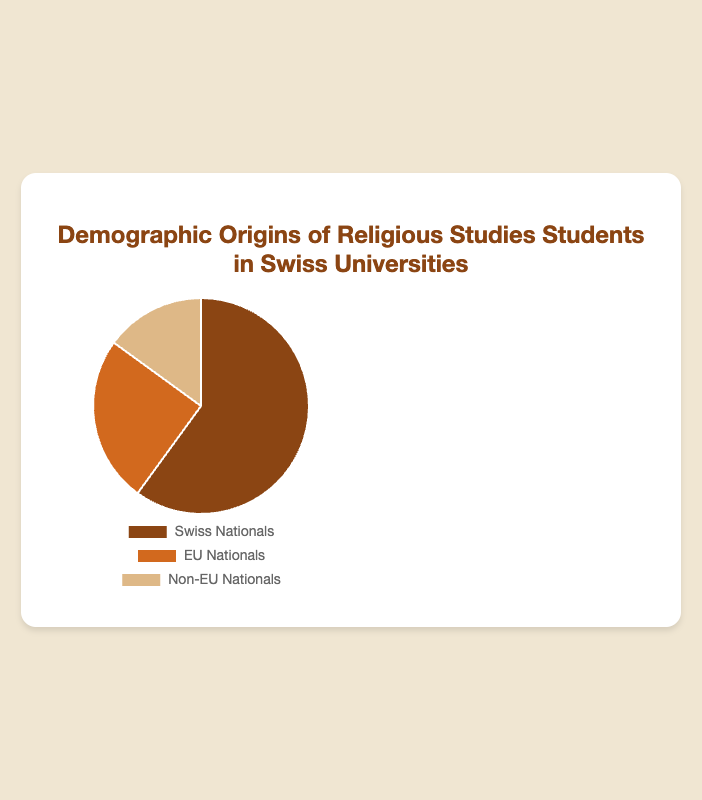Which nationality has the highest percentage of students? From the chart, it is clear that Swiss Nationals have the largest section. We also see that the data point for Swiss Nationals is 60%, which is higher than the other two groups.
Answer: Swiss Nationals Which two nationalities combined make up half of the student population? From the chart data, EU Nationals account for 25% and Non-EU Nationals account for 15%. Their combined percentage is 25% + 15% = 40%. To make up half of the student population (50%), we need another group. Hence, Swiss Nationals account for 60%, leaving the remaining as these two groups combined is not satisfactory.
Answer: No combination What percentage of the students are from non-Swiss nationalities? From the chart data, EU Nationals are 25% and Non-EU Nationals are 15%. Adding these gives 25% + 15% = 40%.
Answer: 40% Are there more EU Nationals or Non-EU Nationals in the religious studies program? From the chart, the portion for EU Nationals is larger than the portion for Non-EU Nationals. Specifically, EU Nationals are 25%, while Non-EU Nationals are 15%.
Answer: EU Nationals What is the visual color used to represent the Swiss Nationals in the chart? From the chart description, Swiss Nationals are represented using the color brown.
Answer: Brown What's the sum of the percentages of Swiss Nationals and EU Nationals? The data shows that Swiss Nationals are 60% and EU Nationals are 25%. Adding these gives 60% + 25% = 85%.
Answer: 85% How much larger is the percentage of Swiss Nationals compared to Non-EU Nationals? Swiss Nationals are 60%, and Non-EU Nationals are 15%. The difference is 60% - 15% = 45%.
Answer: 45% What proportion of the total does each group of nationals represent? Swiss Nationals are 60%, EU Nationals are 25%, Non-EU Nationals are 15%. Together, 60 + 25 + 15 = 100%. So, Swiss Nationals represent 60/100 = 0.60 or 60%, EU Nationals are 25/100 = 0.25 or 25%, Non-EU Nationals are 15/100 = 0.15 or 15%.
Answer: Swiss Nationals (60%), EU Nationals (25%), Non-EU Nationals (15%) Which nationality has the smallest representation? From the data, Non-EU Nationals have a percentage of 15%, which is smaller than Swiss Nationals (60%) and EU Nationals (25%).
Answer: Non-EU Nationals 